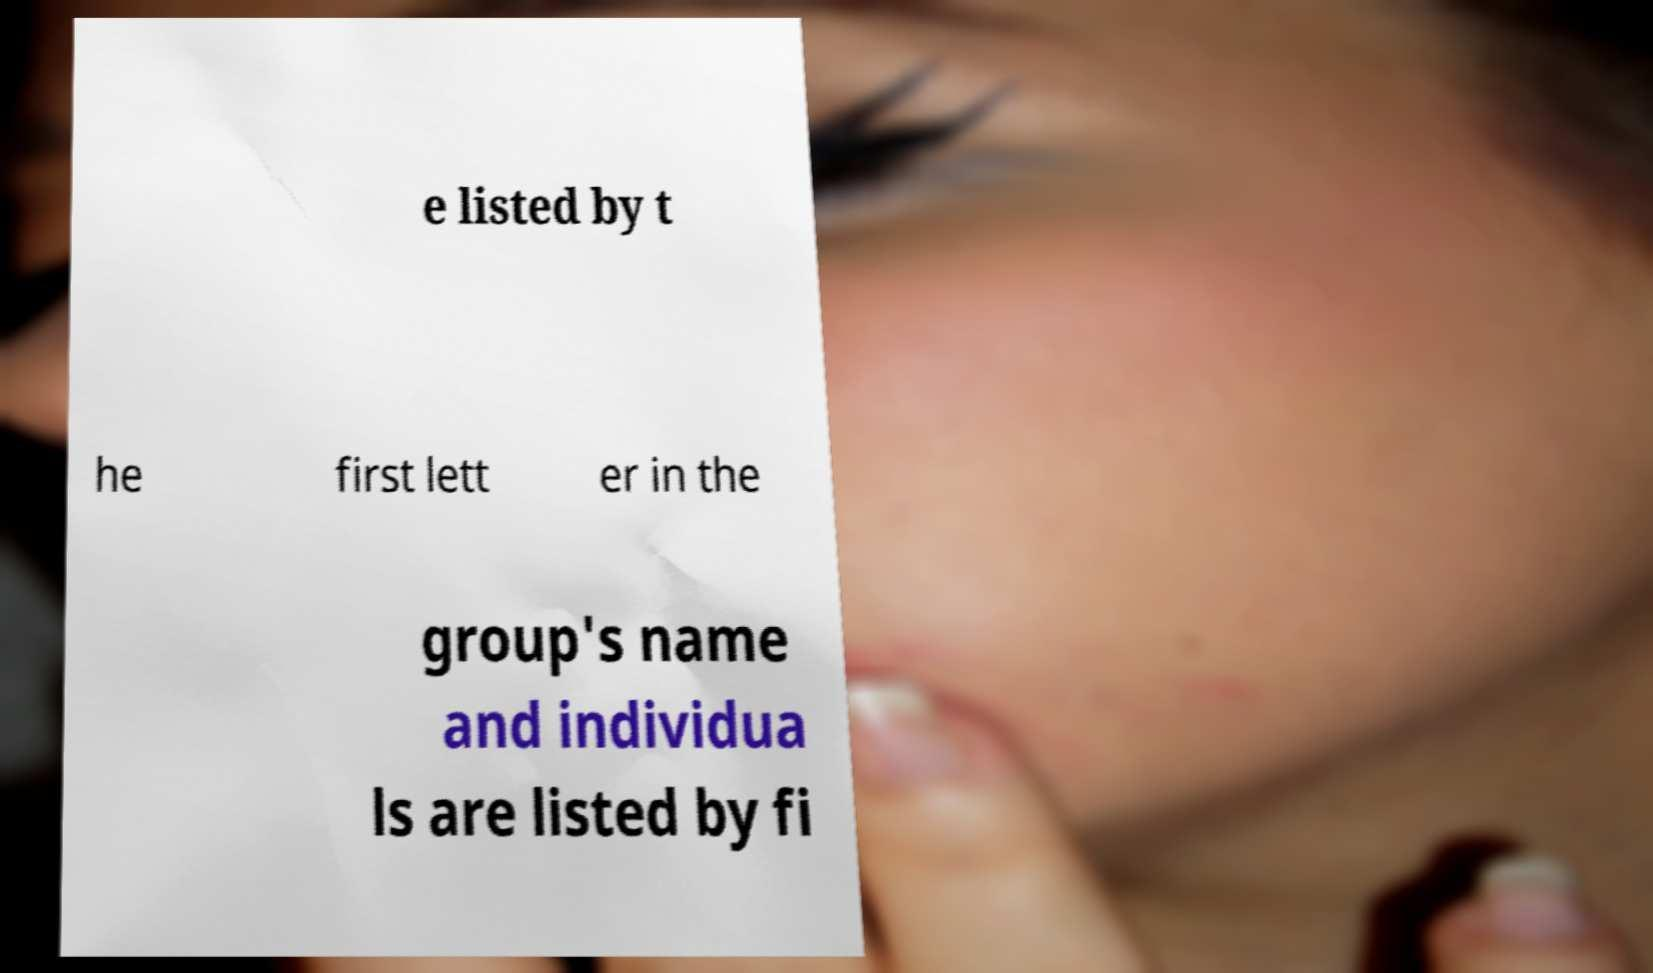Can you accurately transcribe the text from the provided image for me? e listed by t he first lett er in the group's name and individua ls are listed by fi 